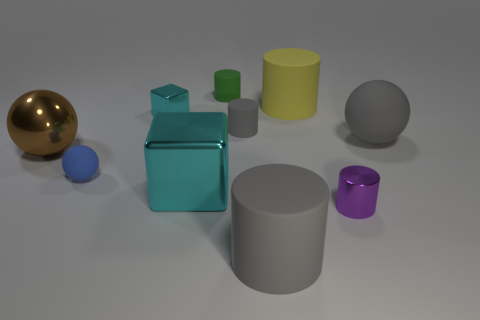There is a large object that is the same color as the large matte sphere; what is its material?
Your answer should be compact. Rubber. Is there a large metallic thing of the same shape as the small cyan object?
Provide a succinct answer. Yes. There is a cyan object that is behind the small blue matte thing; does it have the same shape as the shiny object right of the big cyan metal thing?
Provide a short and direct response. No. How many things are either gray spheres or brown metal cylinders?
Ensure brevity in your answer.  1. There is a gray object that is the same shape as the brown object; what size is it?
Your answer should be compact. Large. Are there more tiny green matte cylinders in front of the brown shiny thing than small metal things?
Make the answer very short. No. Are the tiny purple object and the brown ball made of the same material?
Provide a succinct answer. Yes. What number of objects are either rubber cylinders that are right of the big brown metal ball or rubber cylinders in front of the blue matte thing?
Your response must be concise. 4. What is the color of the other small matte thing that is the same shape as the tiny gray thing?
Provide a succinct answer. Green. What number of metal balls have the same color as the small metallic cube?
Ensure brevity in your answer.  0. 